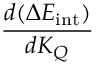Convert formula to latex. <formula><loc_0><loc_0><loc_500><loc_500>\frac { d ( \Delta E _ { i n t } ) } { d K _ { Q } }</formula> 